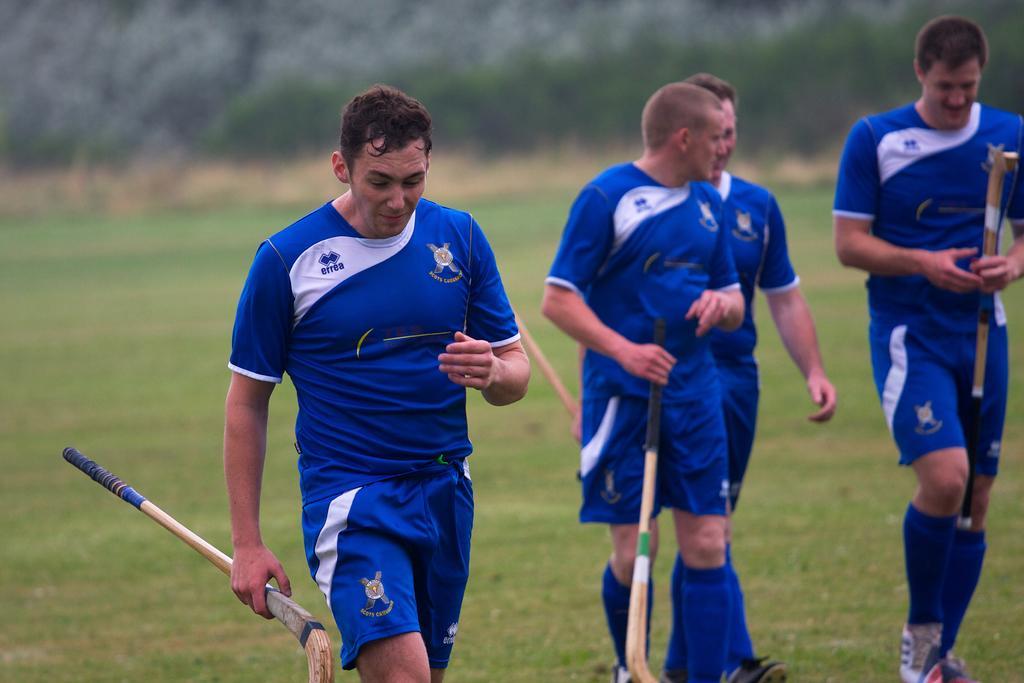Describe this image in one or two sentences. In this picture we can see there are four people holding the hockey sticks and walking on the grass path. Behind the people there is a blurred background. 